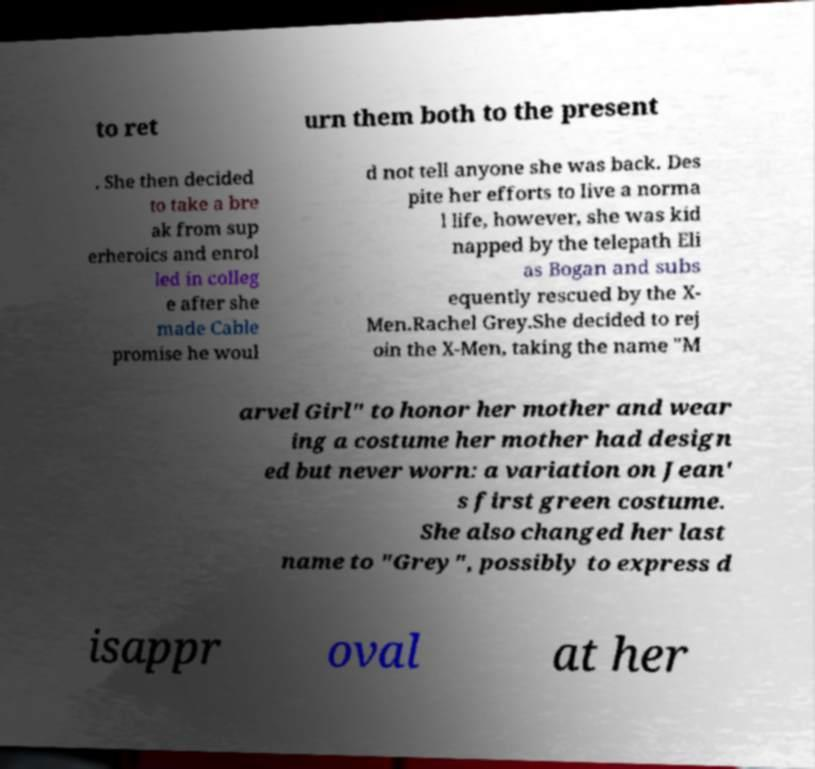Can you accurately transcribe the text from the provided image for me? to ret urn them both to the present . She then decided to take a bre ak from sup erheroics and enrol led in colleg e after she made Cable promise he woul d not tell anyone she was back. Des pite her efforts to live a norma l life, however, she was kid napped by the telepath Eli as Bogan and subs equently rescued by the X- Men.Rachel Grey.She decided to rej oin the X-Men, taking the name "M arvel Girl" to honor her mother and wear ing a costume her mother had design ed but never worn: a variation on Jean' s first green costume. She also changed her last name to "Grey", possibly to express d isappr oval at her 